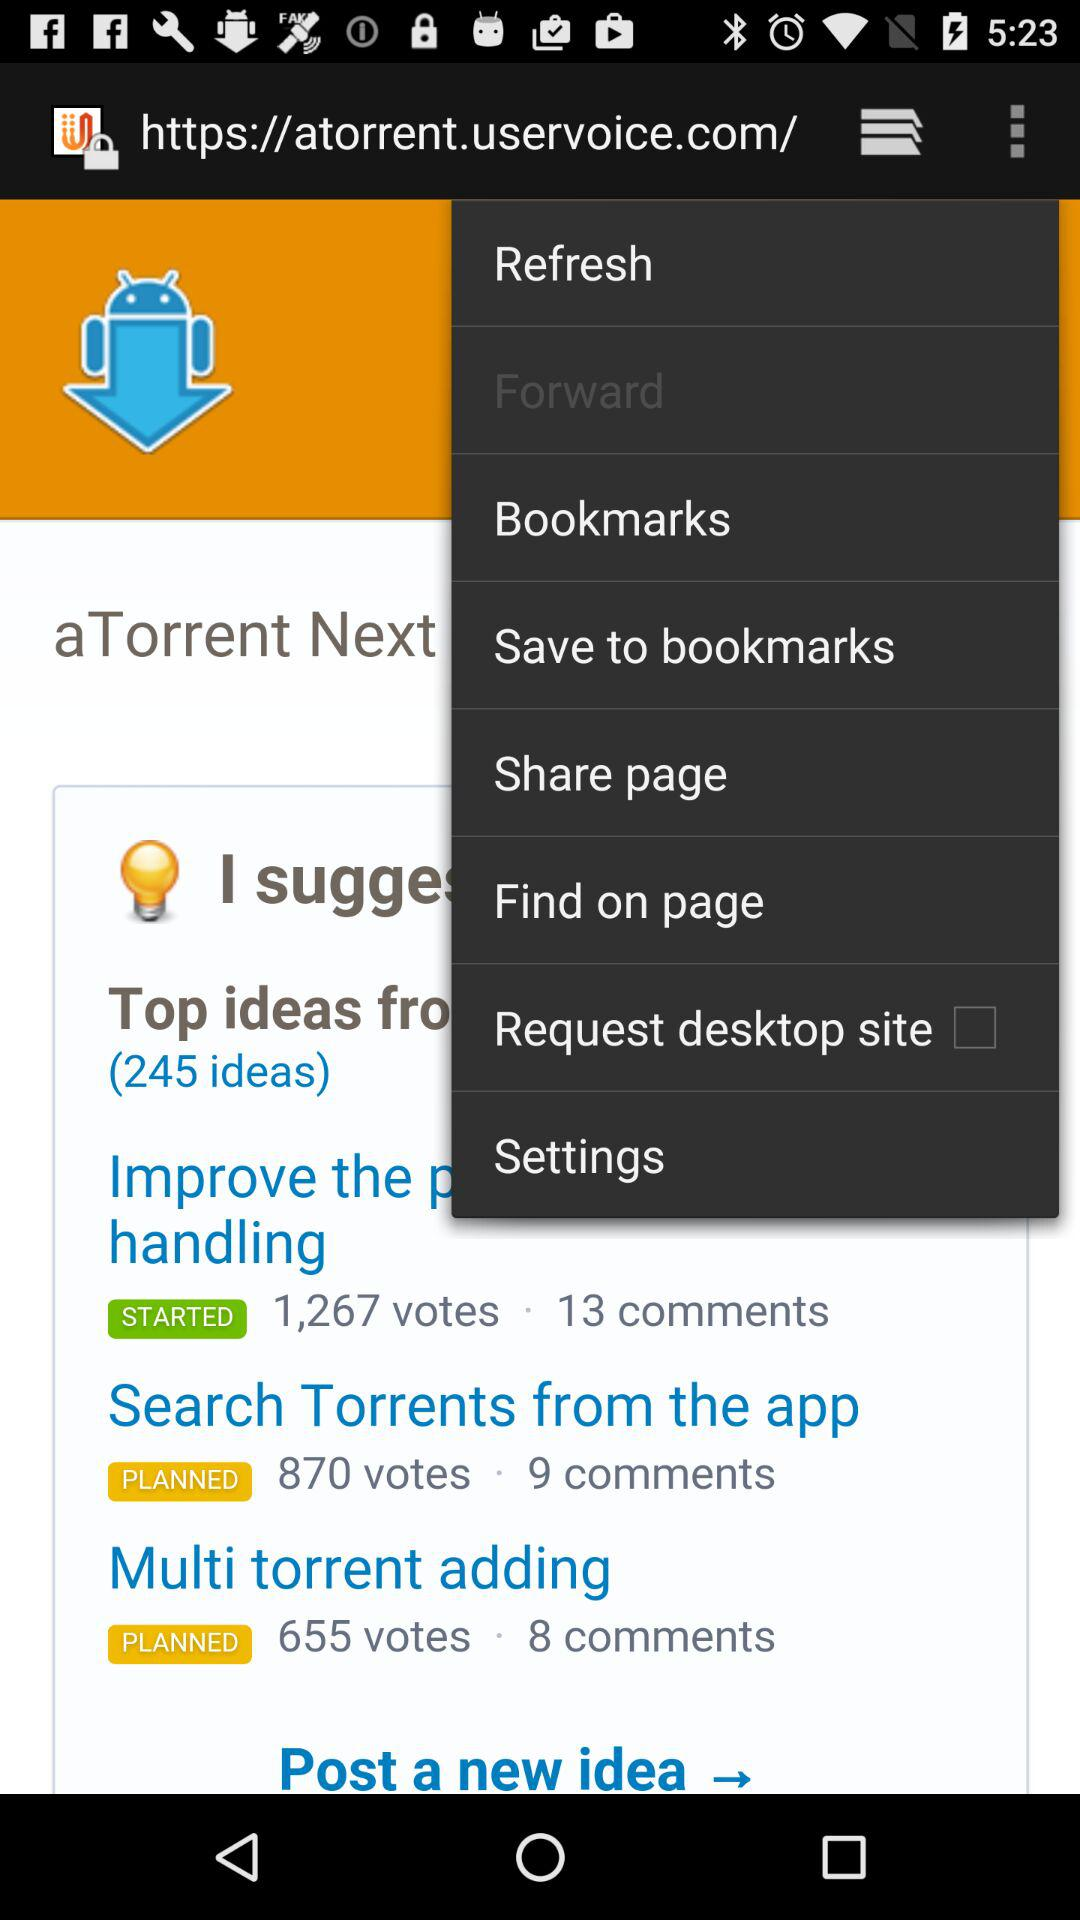Which option is unchecked? The unchecked option is "Request desktop site". 